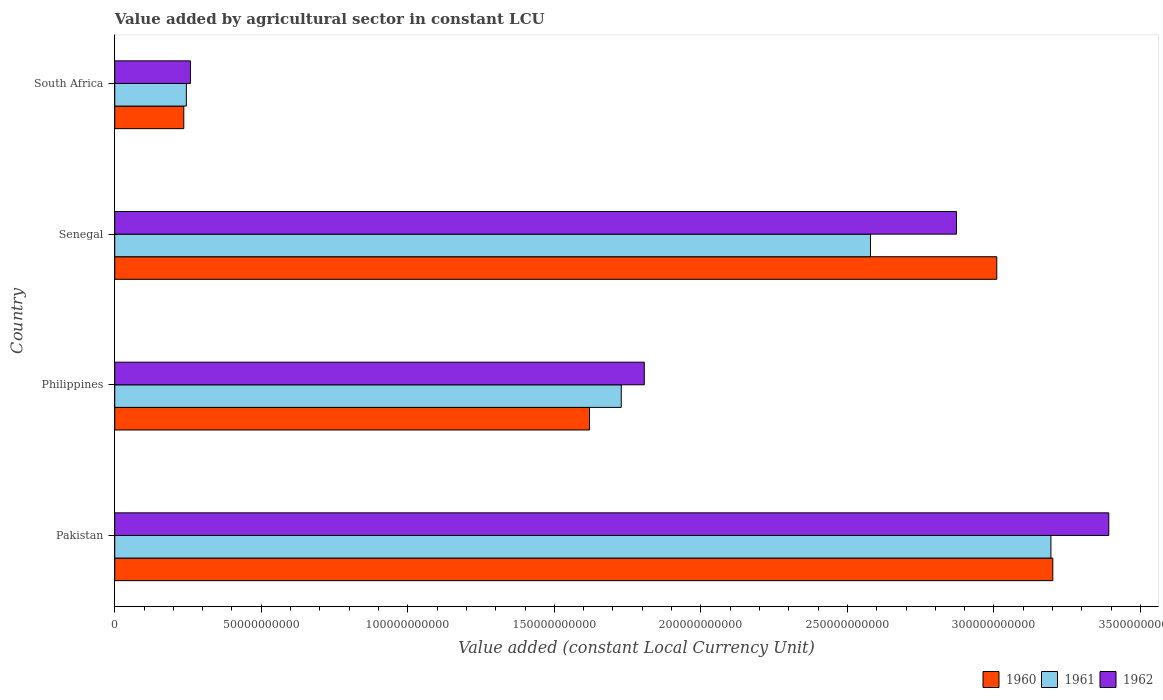How many groups of bars are there?
Keep it short and to the point. 4. Are the number of bars per tick equal to the number of legend labels?
Your answer should be very brief. Yes. How many bars are there on the 4th tick from the top?
Offer a terse response. 3. How many bars are there on the 2nd tick from the bottom?
Offer a terse response. 3. What is the label of the 1st group of bars from the top?
Your response must be concise. South Africa. In how many cases, is the number of bars for a given country not equal to the number of legend labels?
Your answer should be compact. 0. What is the value added by agricultural sector in 1961 in Senegal?
Your answer should be very brief. 2.58e+11. Across all countries, what is the maximum value added by agricultural sector in 1962?
Keep it short and to the point. 3.39e+11. Across all countries, what is the minimum value added by agricultural sector in 1962?
Your answer should be very brief. 2.58e+1. In which country was the value added by agricultural sector in 1962 minimum?
Keep it short and to the point. South Africa. What is the total value added by agricultural sector in 1960 in the graph?
Provide a short and direct response. 8.07e+11. What is the difference between the value added by agricultural sector in 1961 in Senegal and that in South Africa?
Keep it short and to the point. 2.33e+11. What is the difference between the value added by agricultural sector in 1962 in South Africa and the value added by agricultural sector in 1961 in Pakistan?
Keep it short and to the point. -2.94e+11. What is the average value added by agricultural sector in 1962 per country?
Offer a terse response. 2.08e+11. What is the difference between the value added by agricultural sector in 1961 and value added by agricultural sector in 1962 in Senegal?
Give a very brief answer. -2.93e+1. What is the ratio of the value added by agricultural sector in 1961 in Senegal to that in South Africa?
Give a very brief answer. 10.55. Is the value added by agricultural sector in 1960 in Philippines less than that in South Africa?
Provide a succinct answer. No. Is the difference between the value added by agricultural sector in 1961 in Pakistan and Senegal greater than the difference between the value added by agricultural sector in 1962 in Pakistan and Senegal?
Your answer should be very brief. Yes. What is the difference between the highest and the second highest value added by agricultural sector in 1960?
Provide a succinct answer. 1.91e+1. What is the difference between the highest and the lowest value added by agricultural sector in 1960?
Offer a terse response. 2.97e+11. In how many countries, is the value added by agricultural sector in 1960 greater than the average value added by agricultural sector in 1960 taken over all countries?
Offer a very short reply. 2. Is the sum of the value added by agricultural sector in 1961 in Pakistan and South Africa greater than the maximum value added by agricultural sector in 1960 across all countries?
Make the answer very short. Yes. What does the 1st bar from the top in Pakistan represents?
Provide a short and direct response. 1962. What is the difference between two consecutive major ticks on the X-axis?
Offer a very short reply. 5.00e+1. Are the values on the major ticks of X-axis written in scientific E-notation?
Your answer should be compact. No. Does the graph contain any zero values?
Provide a short and direct response. No. Where does the legend appear in the graph?
Provide a short and direct response. Bottom right. How are the legend labels stacked?
Provide a short and direct response. Horizontal. What is the title of the graph?
Make the answer very short. Value added by agricultural sector in constant LCU. What is the label or title of the X-axis?
Ensure brevity in your answer.  Value added (constant Local Currency Unit). What is the Value added (constant Local Currency Unit) of 1960 in Pakistan?
Give a very brief answer. 3.20e+11. What is the Value added (constant Local Currency Unit) in 1961 in Pakistan?
Your response must be concise. 3.19e+11. What is the Value added (constant Local Currency Unit) in 1962 in Pakistan?
Offer a very short reply. 3.39e+11. What is the Value added (constant Local Currency Unit) of 1960 in Philippines?
Provide a succinct answer. 1.62e+11. What is the Value added (constant Local Currency Unit) of 1961 in Philippines?
Give a very brief answer. 1.73e+11. What is the Value added (constant Local Currency Unit) in 1962 in Philippines?
Make the answer very short. 1.81e+11. What is the Value added (constant Local Currency Unit) of 1960 in Senegal?
Provide a short and direct response. 3.01e+11. What is the Value added (constant Local Currency Unit) in 1961 in Senegal?
Make the answer very short. 2.58e+11. What is the Value added (constant Local Currency Unit) of 1962 in Senegal?
Ensure brevity in your answer.  2.87e+11. What is the Value added (constant Local Currency Unit) in 1960 in South Africa?
Keep it short and to the point. 2.36e+1. What is the Value added (constant Local Currency Unit) in 1961 in South Africa?
Make the answer very short. 2.44e+1. What is the Value added (constant Local Currency Unit) of 1962 in South Africa?
Make the answer very short. 2.58e+1. Across all countries, what is the maximum Value added (constant Local Currency Unit) of 1960?
Offer a very short reply. 3.20e+11. Across all countries, what is the maximum Value added (constant Local Currency Unit) of 1961?
Provide a short and direct response. 3.19e+11. Across all countries, what is the maximum Value added (constant Local Currency Unit) in 1962?
Provide a short and direct response. 3.39e+11. Across all countries, what is the minimum Value added (constant Local Currency Unit) of 1960?
Your answer should be compact. 2.36e+1. Across all countries, what is the minimum Value added (constant Local Currency Unit) in 1961?
Your answer should be compact. 2.44e+1. Across all countries, what is the minimum Value added (constant Local Currency Unit) of 1962?
Give a very brief answer. 2.58e+1. What is the total Value added (constant Local Currency Unit) in 1960 in the graph?
Provide a succinct answer. 8.07e+11. What is the total Value added (constant Local Currency Unit) of 1961 in the graph?
Keep it short and to the point. 7.75e+11. What is the total Value added (constant Local Currency Unit) in 1962 in the graph?
Make the answer very short. 8.33e+11. What is the difference between the Value added (constant Local Currency Unit) of 1960 in Pakistan and that in Philippines?
Provide a succinct answer. 1.58e+11. What is the difference between the Value added (constant Local Currency Unit) of 1961 in Pakistan and that in Philippines?
Give a very brief answer. 1.47e+11. What is the difference between the Value added (constant Local Currency Unit) in 1962 in Pakistan and that in Philippines?
Your answer should be compact. 1.58e+11. What is the difference between the Value added (constant Local Currency Unit) in 1960 in Pakistan and that in Senegal?
Make the answer very short. 1.91e+1. What is the difference between the Value added (constant Local Currency Unit) of 1961 in Pakistan and that in Senegal?
Your answer should be compact. 6.16e+1. What is the difference between the Value added (constant Local Currency Unit) of 1962 in Pakistan and that in Senegal?
Provide a succinct answer. 5.20e+1. What is the difference between the Value added (constant Local Currency Unit) in 1960 in Pakistan and that in South Africa?
Offer a terse response. 2.97e+11. What is the difference between the Value added (constant Local Currency Unit) of 1961 in Pakistan and that in South Africa?
Your answer should be very brief. 2.95e+11. What is the difference between the Value added (constant Local Currency Unit) of 1962 in Pakistan and that in South Africa?
Provide a short and direct response. 3.13e+11. What is the difference between the Value added (constant Local Currency Unit) in 1960 in Philippines and that in Senegal?
Provide a succinct answer. -1.39e+11. What is the difference between the Value added (constant Local Currency Unit) in 1961 in Philippines and that in Senegal?
Make the answer very short. -8.50e+1. What is the difference between the Value added (constant Local Currency Unit) of 1962 in Philippines and that in Senegal?
Offer a terse response. -1.07e+11. What is the difference between the Value added (constant Local Currency Unit) of 1960 in Philippines and that in South Africa?
Keep it short and to the point. 1.38e+11. What is the difference between the Value added (constant Local Currency Unit) of 1961 in Philippines and that in South Africa?
Give a very brief answer. 1.48e+11. What is the difference between the Value added (constant Local Currency Unit) in 1962 in Philippines and that in South Africa?
Provide a short and direct response. 1.55e+11. What is the difference between the Value added (constant Local Currency Unit) in 1960 in Senegal and that in South Africa?
Offer a very short reply. 2.77e+11. What is the difference between the Value added (constant Local Currency Unit) in 1961 in Senegal and that in South Africa?
Give a very brief answer. 2.33e+11. What is the difference between the Value added (constant Local Currency Unit) in 1962 in Senegal and that in South Africa?
Give a very brief answer. 2.61e+11. What is the difference between the Value added (constant Local Currency Unit) of 1960 in Pakistan and the Value added (constant Local Currency Unit) of 1961 in Philippines?
Make the answer very short. 1.47e+11. What is the difference between the Value added (constant Local Currency Unit) in 1960 in Pakistan and the Value added (constant Local Currency Unit) in 1962 in Philippines?
Provide a short and direct response. 1.39e+11. What is the difference between the Value added (constant Local Currency Unit) in 1961 in Pakistan and the Value added (constant Local Currency Unit) in 1962 in Philippines?
Offer a very short reply. 1.39e+11. What is the difference between the Value added (constant Local Currency Unit) of 1960 in Pakistan and the Value added (constant Local Currency Unit) of 1961 in Senegal?
Your answer should be compact. 6.22e+1. What is the difference between the Value added (constant Local Currency Unit) of 1960 in Pakistan and the Value added (constant Local Currency Unit) of 1962 in Senegal?
Offer a terse response. 3.29e+1. What is the difference between the Value added (constant Local Currency Unit) of 1961 in Pakistan and the Value added (constant Local Currency Unit) of 1962 in Senegal?
Make the answer very short. 3.22e+1. What is the difference between the Value added (constant Local Currency Unit) of 1960 in Pakistan and the Value added (constant Local Currency Unit) of 1961 in South Africa?
Provide a succinct answer. 2.96e+11. What is the difference between the Value added (constant Local Currency Unit) of 1960 in Pakistan and the Value added (constant Local Currency Unit) of 1962 in South Africa?
Keep it short and to the point. 2.94e+11. What is the difference between the Value added (constant Local Currency Unit) in 1961 in Pakistan and the Value added (constant Local Currency Unit) in 1962 in South Africa?
Give a very brief answer. 2.94e+11. What is the difference between the Value added (constant Local Currency Unit) in 1960 in Philippines and the Value added (constant Local Currency Unit) in 1961 in Senegal?
Give a very brief answer. -9.59e+1. What is the difference between the Value added (constant Local Currency Unit) of 1960 in Philippines and the Value added (constant Local Currency Unit) of 1962 in Senegal?
Give a very brief answer. -1.25e+11. What is the difference between the Value added (constant Local Currency Unit) of 1961 in Philippines and the Value added (constant Local Currency Unit) of 1962 in Senegal?
Keep it short and to the point. -1.14e+11. What is the difference between the Value added (constant Local Currency Unit) in 1960 in Philippines and the Value added (constant Local Currency Unit) in 1961 in South Africa?
Provide a succinct answer. 1.38e+11. What is the difference between the Value added (constant Local Currency Unit) in 1960 in Philippines and the Value added (constant Local Currency Unit) in 1962 in South Africa?
Keep it short and to the point. 1.36e+11. What is the difference between the Value added (constant Local Currency Unit) in 1961 in Philippines and the Value added (constant Local Currency Unit) in 1962 in South Africa?
Provide a succinct answer. 1.47e+11. What is the difference between the Value added (constant Local Currency Unit) of 1960 in Senegal and the Value added (constant Local Currency Unit) of 1961 in South Africa?
Your answer should be very brief. 2.77e+11. What is the difference between the Value added (constant Local Currency Unit) of 1960 in Senegal and the Value added (constant Local Currency Unit) of 1962 in South Africa?
Your answer should be very brief. 2.75e+11. What is the difference between the Value added (constant Local Currency Unit) in 1961 in Senegal and the Value added (constant Local Currency Unit) in 1962 in South Africa?
Offer a terse response. 2.32e+11. What is the average Value added (constant Local Currency Unit) in 1960 per country?
Make the answer very short. 2.02e+11. What is the average Value added (constant Local Currency Unit) of 1961 per country?
Your answer should be compact. 1.94e+11. What is the average Value added (constant Local Currency Unit) of 1962 per country?
Keep it short and to the point. 2.08e+11. What is the difference between the Value added (constant Local Currency Unit) of 1960 and Value added (constant Local Currency Unit) of 1961 in Pakistan?
Provide a short and direct response. 6.46e+08. What is the difference between the Value added (constant Local Currency Unit) of 1960 and Value added (constant Local Currency Unit) of 1962 in Pakistan?
Make the answer very short. -1.91e+1. What is the difference between the Value added (constant Local Currency Unit) of 1961 and Value added (constant Local Currency Unit) of 1962 in Pakistan?
Offer a terse response. -1.97e+1. What is the difference between the Value added (constant Local Currency Unit) in 1960 and Value added (constant Local Currency Unit) in 1961 in Philippines?
Offer a very short reply. -1.08e+1. What is the difference between the Value added (constant Local Currency Unit) of 1960 and Value added (constant Local Currency Unit) of 1962 in Philippines?
Your answer should be very brief. -1.87e+1. What is the difference between the Value added (constant Local Currency Unit) of 1961 and Value added (constant Local Currency Unit) of 1962 in Philippines?
Your answer should be compact. -7.86e+09. What is the difference between the Value added (constant Local Currency Unit) in 1960 and Value added (constant Local Currency Unit) in 1961 in Senegal?
Your answer should be very brief. 4.31e+1. What is the difference between the Value added (constant Local Currency Unit) of 1960 and Value added (constant Local Currency Unit) of 1962 in Senegal?
Your answer should be compact. 1.38e+1. What is the difference between the Value added (constant Local Currency Unit) in 1961 and Value added (constant Local Currency Unit) in 1962 in Senegal?
Offer a terse response. -2.93e+1. What is the difference between the Value added (constant Local Currency Unit) of 1960 and Value added (constant Local Currency Unit) of 1961 in South Africa?
Your answer should be compact. -8.75e+08. What is the difference between the Value added (constant Local Currency Unit) of 1960 and Value added (constant Local Currency Unit) of 1962 in South Africa?
Ensure brevity in your answer.  -2.26e+09. What is the difference between the Value added (constant Local Currency Unit) in 1961 and Value added (constant Local Currency Unit) in 1962 in South Africa?
Your answer should be very brief. -1.39e+09. What is the ratio of the Value added (constant Local Currency Unit) of 1960 in Pakistan to that in Philippines?
Your answer should be very brief. 1.98. What is the ratio of the Value added (constant Local Currency Unit) in 1961 in Pakistan to that in Philippines?
Your answer should be compact. 1.85. What is the ratio of the Value added (constant Local Currency Unit) in 1962 in Pakistan to that in Philippines?
Give a very brief answer. 1.88. What is the ratio of the Value added (constant Local Currency Unit) of 1960 in Pakistan to that in Senegal?
Offer a very short reply. 1.06. What is the ratio of the Value added (constant Local Currency Unit) of 1961 in Pakistan to that in Senegal?
Your answer should be very brief. 1.24. What is the ratio of the Value added (constant Local Currency Unit) of 1962 in Pakistan to that in Senegal?
Your answer should be very brief. 1.18. What is the ratio of the Value added (constant Local Currency Unit) of 1960 in Pakistan to that in South Africa?
Provide a short and direct response. 13.59. What is the ratio of the Value added (constant Local Currency Unit) of 1961 in Pakistan to that in South Africa?
Your response must be concise. 13.07. What is the ratio of the Value added (constant Local Currency Unit) of 1962 in Pakistan to that in South Africa?
Your answer should be very brief. 13.14. What is the ratio of the Value added (constant Local Currency Unit) of 1960 in Philippines to that in Senegal?
Your answer should be very brief. 0.54. What is the ratio of the Value added (constant Local Currency Unit) in 1961 in Philippines to that in Senegal?
Keep it short and to the point. 0.67. What is the ratio of the Value added (constant Local Currency Unit) in 1962 in Philippines to that in Senegal?
Your answer should be compact. 0.63. What is the ratio of the Value added (constant Local Currency Unit) in 1960 in Philippines to that in South Africa?
Offer a very short reply. 6.88. What is the ratio of the Value added (constant Local Currency Unit) in 1961 in Philippines to that in South Africa?
Provide a succinct answer. 7.07. What is the ratio of the Value added (constant Local Currency Unit) in 1962 in Philippines to that in South Africa?
Offer a terse response. 7. What is the ratio of the Value added (constant Local Currency Unit) in 1960 in Senegal to that in South Africa?
Your answer should be compact. 12.77. What is the ratio of the Value added (constant Local Currency Unit) in 1961 in Senegal to that in South Africa?
Your answer should be very brief. 10.55. What is the ratio of the Value added (constant Local Currency Unit) in 1962 in Senegal to that in South Africa?
Your answer should be very brief. 11.12. What is the difference between the highest and the second highest Value added (constant Local Currency Unit) in 1960?
Your answer should be very brief. 1.91e+1. What is the difference between the highest and the second highest Value added (constant Local Currency Unit) of 1961?
Ensure brevity in your answer.  6.16e+1. What is the difference between the highest and the second highest Value added (constant Local Currency Unit) of 1962?
Ensure brevity in your answer.  5.20e+1. What is the difference between the highest and the lowest Value added (constant Local Currency Unit) in 1960?
Provide a short and direct response. 2.97e+11. What is the difference between the highest and the lowest Value added (constant Local Currency Unit) of 1961?
Provide a succinct answer. 2.95e+11. What is the difference between the highest and the lowest Value added (constant Local Currency Unit) of 1962?
Offer a very short reply. 3.13e+11. 